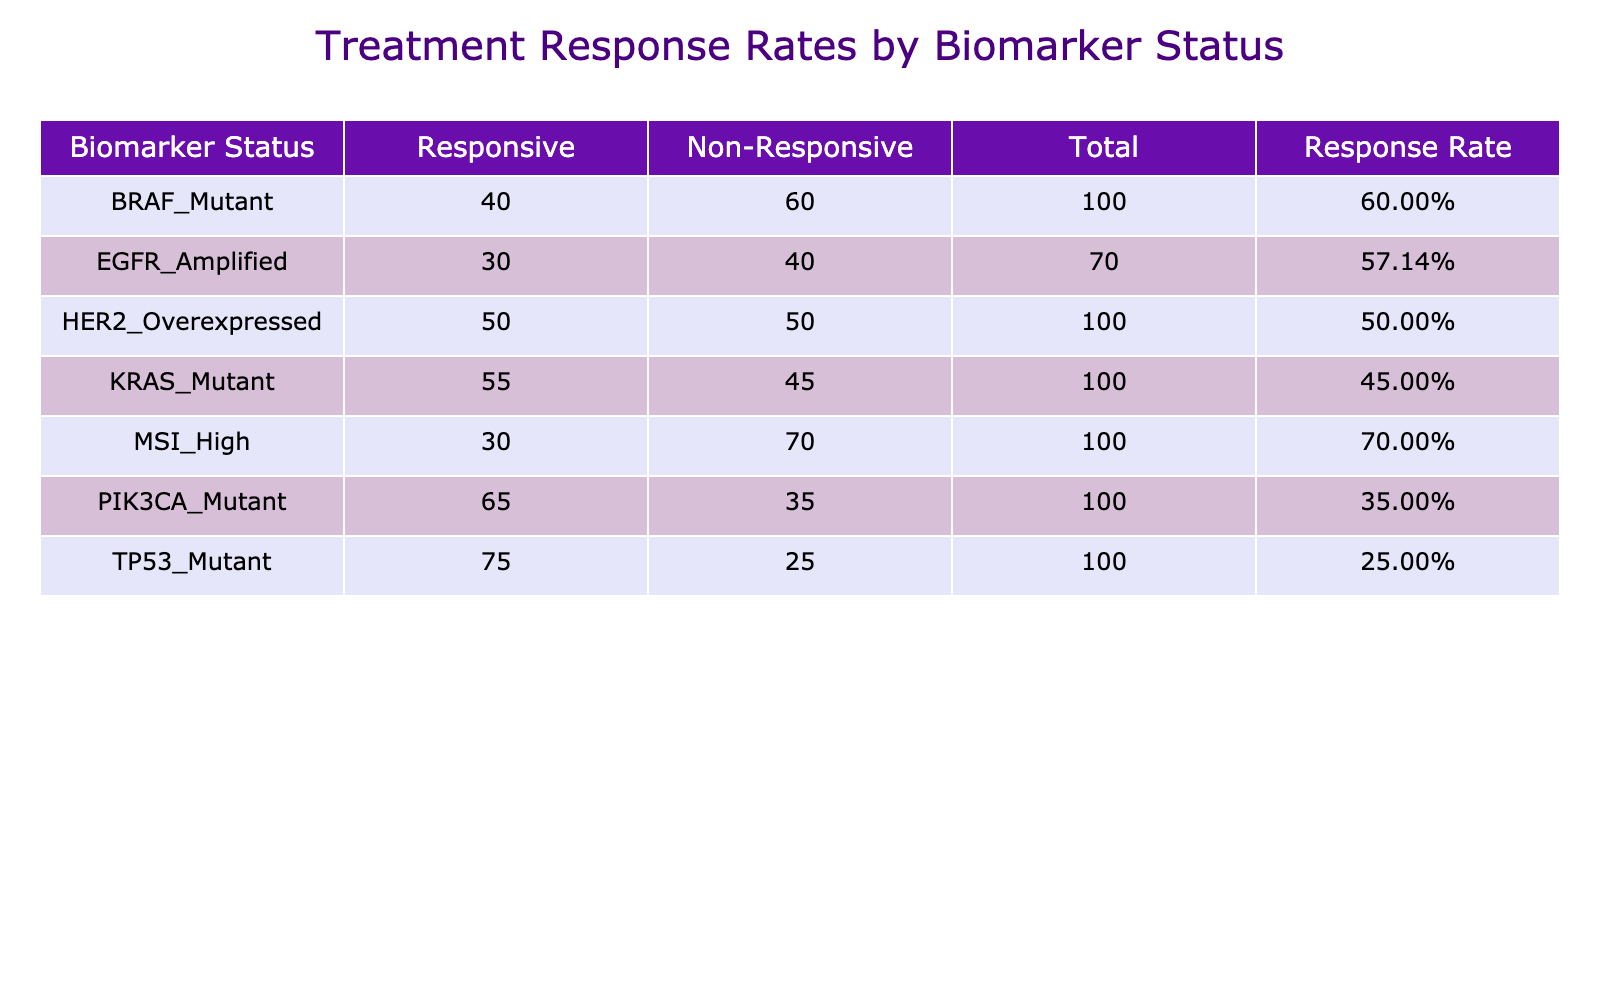What is the treatment response count for patients with KRAS Mutant status? The table shows that for KRAS Mutant status, the responsive count is 45 and the non-responsive count is 55. Thus, the total treatment response count is 45 + 55 = 100.
Answer: 100 What is the overall response rate for EGFR Amplified patients? The treatment response count for EGFR Amplified status includes 40 responsive cases and 30 non-responsive cases, totaling 70. Response rate is calculated as responsive count divided by total count: (40 / 70) = 0.57 or 57.14%.
Answer: 57.14% Is the response rate higher for MSI High patients compared to TP53 Mutant patients? For MSI High patients, the response rate is calculated as 70 responsive cases out of a total of 100 (70 + 30), resulting in a 70% response rate. For TP53 Mutant patients, the response rate is 25 responsive out of 100 (25 + 75), which equals a 25% response rate. As 70% is higher than 25%, the answer is yes.
Answer: Yes What is the difference in the number of responsive cases between BRAF Mutant and HER2 Overexpressed patients? BRAF Mutant patients have 60 responsive cases, while HER2 Overexpressed patients have 50 responsive cases. The difference can be calculated as: 60 - 50 = 10. Thus, BRAF Mutant patients have 10 more responsive cases than HER2 Overexpressed patients.
Answer: 10 Which biomarker status has the highest treatment response count? From the data, we can see that KRAS Mutant has 45 responsive cases and 55 non-responsive cases, totaling 100 cases. However, the highest number of responsive cases is observed in MSI High patients with 70 responsive cases and 30 non-responsive cases, aggregating to 100. Therefore, no single biomarker status has a greater count than 100.
Answer: None, all are 100 What are the total counts of responsive cases across all biomarker statuses? To find the total count of responsive cases, we need to sum up the responsive counts from all categories: 45 (KRAS) + 40 (EGFR) + 25 (TP53) + 35 (PIK3CA) + 50 (HER2) + 60 (BRAF) + 70 (MSI) = 325.
Answer: 325 Does the TP53 Mutant status have a higher number of total cases than the PIK3CA Mutant status? The total cases for TP53 Mutant are 100 (25 responsive + 75 non-responsive), while PIK3CA Mutant has a total of 100 (35 responsive + 65 non-responsive). Therefore, both statuses have equal total cases, and TP53 Mutant does not have a higher total than PIK3CA Mutant.
Answer: No What is the average response rate among all the biomarker statuses? To calculate the average response rate, we need to find the response rates for each biomarker status. The sum of the responsive cases is 325, and the total cases across all biomarkers is 600 (responsive + non-responsive). Hence, the average response rate = (325/600) = 0.54 = 54%.
Answer: 54% 